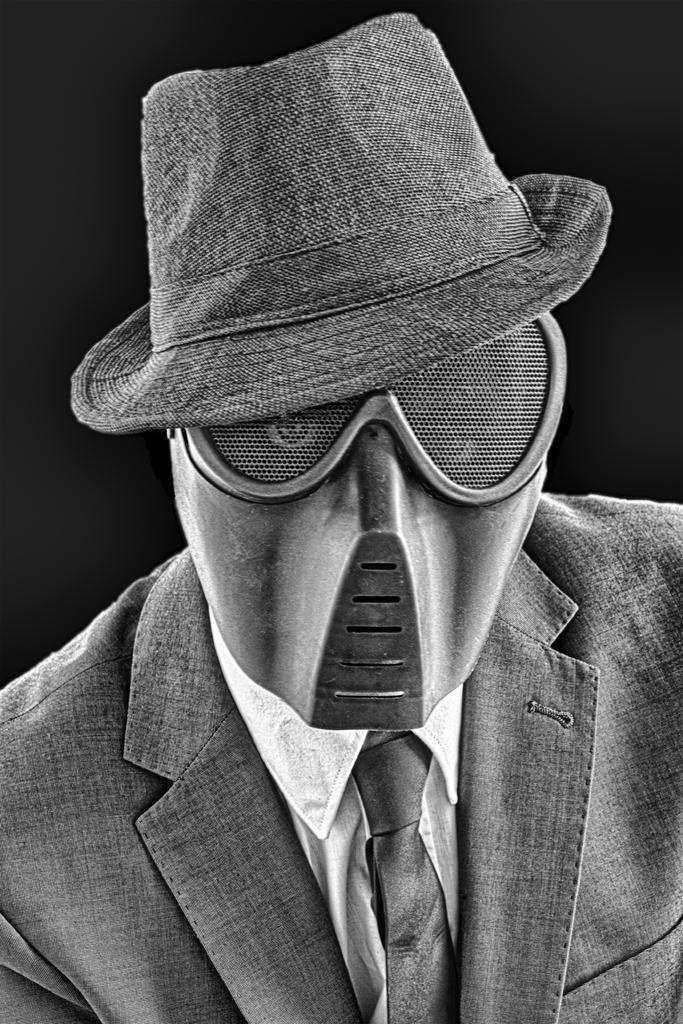In one or two sentences, can you explain what this image depicts? In the image we can see a person. He wears a cap and mask. 